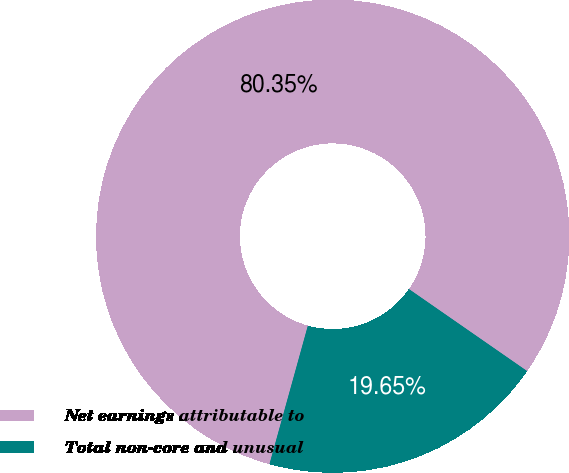Convert chart. <chart><loc_0><loc_0><loc_500><loc_500><pie_chart><fcel>Net earnings attributable to<fcel>Total non-core and unusual<nl><fcel>80.35%<fcel>19.65%<nl></chart> 